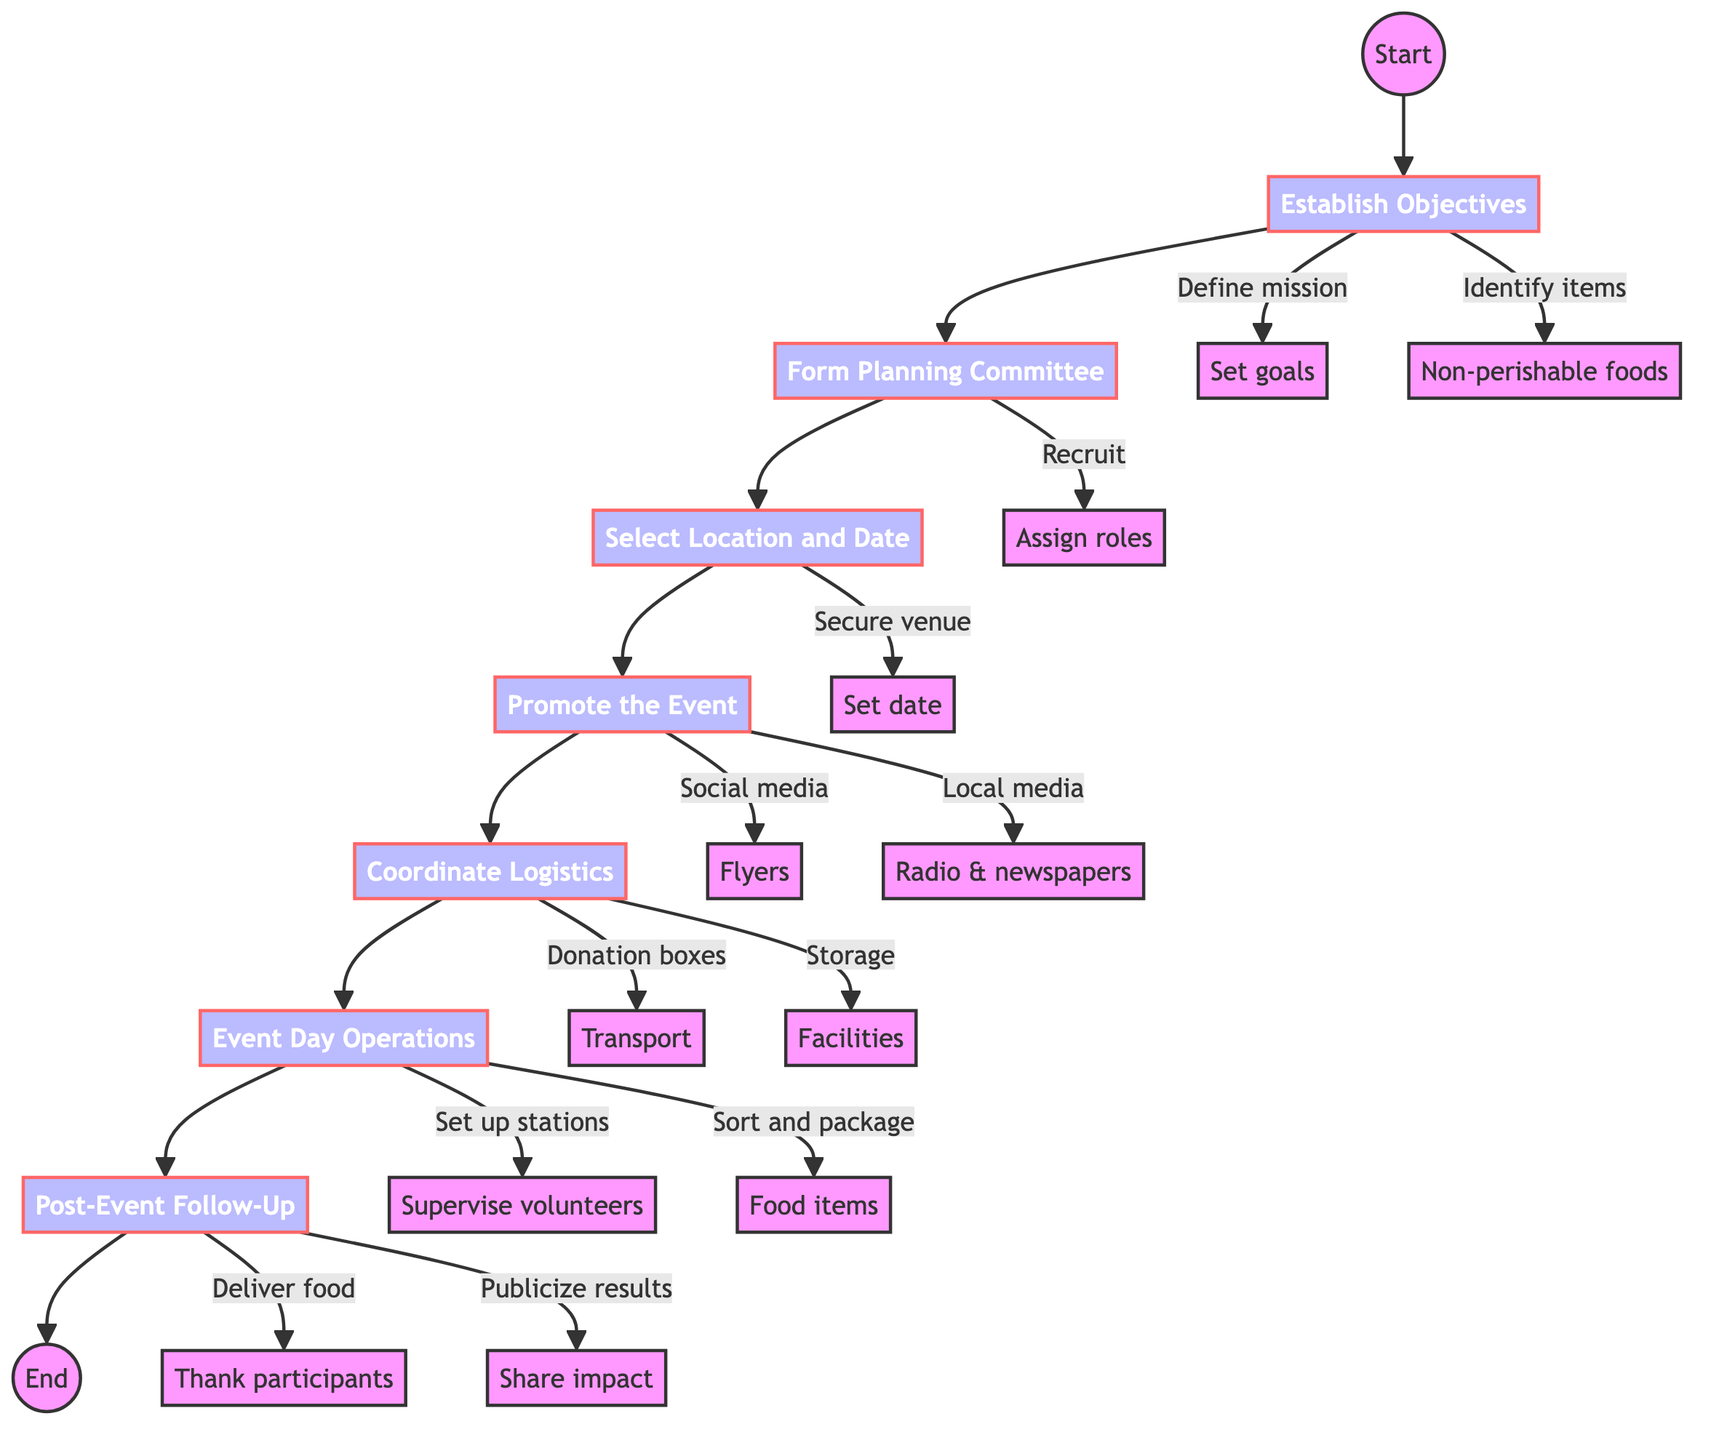What is the first step in organizing a community food drive? The first step is labeled as "Establish Objectives", which is clearly indicated in the diagram as the initial action to take.
Answer: Establish Objectives How many main steps are there in the food drive process? By counting the steps represented in the diagram, there are seven main steps listed in sequential order.
Answer: Seven What is the last action taken after the event according to the diagram? The last action in the flowchart outlines "Post-Event Follow-Up", which includes delivering food to the food bank and thanking participants, as part of wrapping up the event.
Answer: Post-Event Follow-Up Which step involves selecting a venue for the food drive? "Select Location and Date" is the step where the venue is secured for the food drive, as indicated by the direct flow from the previous step.
Answer: Select Location and Date What key action is associated with "Promote the Event"? The key actions under "Promote the Event" include utilizing social media platforms, distributing flyers, and reaching out to local media, which are explicitly listed in the subsequent content under that step.
Answer: Utilize social media platforms What happens after the "Coordinate Logistics" step? After "Coordinate Logistics", the next step according to the flowchart is "Event Day Operations", indicating the transition to managing the actual event.
Answer: Event Day Operations What does the key action labeled 'Thank volunteers and participants' belong to? This action is part of the final step, "Post-Event Follow-Up", highlighting its importance in community acknowledgment after the drive.
Answer: Post-Event Follow-Up What specific task follows collecting donation boxes in "Coordinate Logistics"? "Arrange transportation for collected food items" directly follows collecting donation boxes as a necessary logistical task in the process.
Answer: Arrange transportation for collected food items 